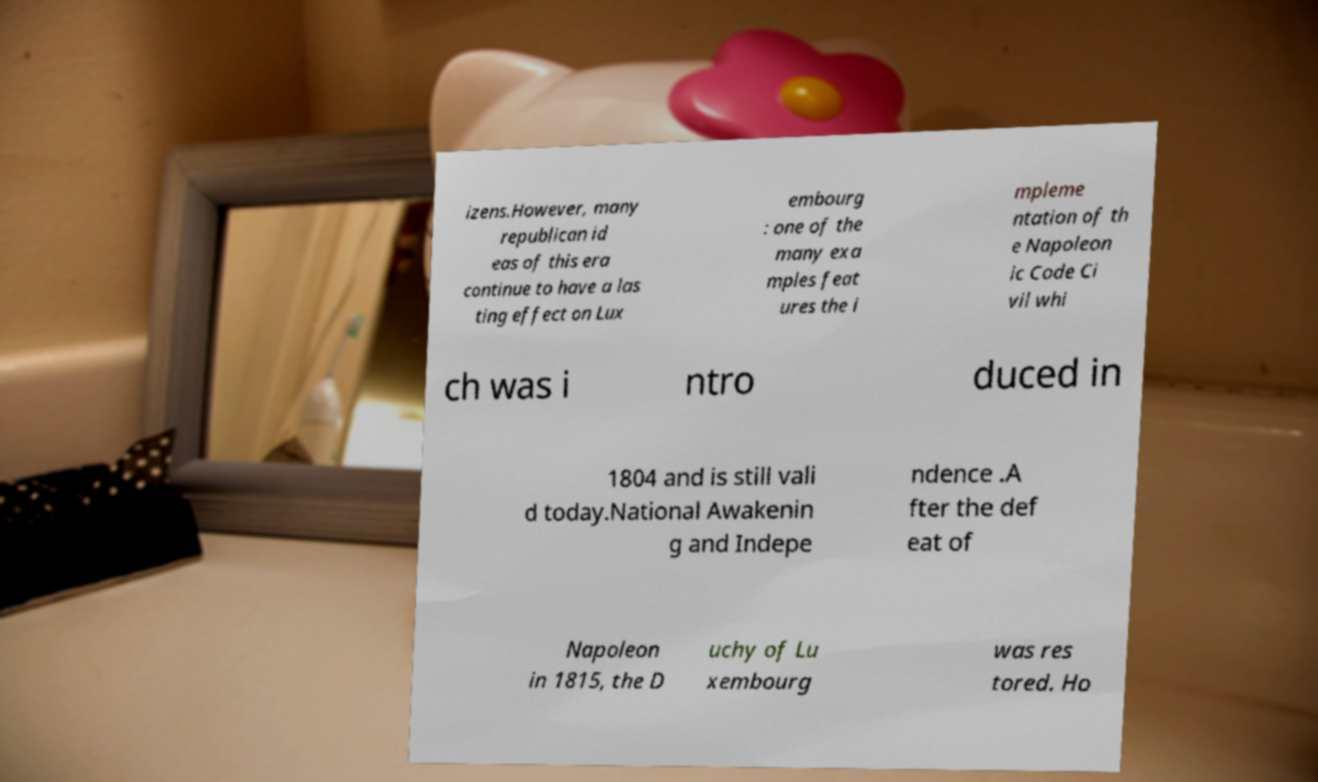What messages or text are displayed in this image? I need them in a readable, typed format. izens.However, many republican id eas of this era continue to have a las ting effect on Lux embourg : one of the many exa mples feat ures the i mpleme ntation of th e Napoleon ic Code Ci vil whi ch was i ntro duced in 1804 and is still vali d today.National Awakenin g and Indepe ndence .A fter the def eat of Napoleon in 1815, the D uchy of Lu xembourg was res tored. Ho 